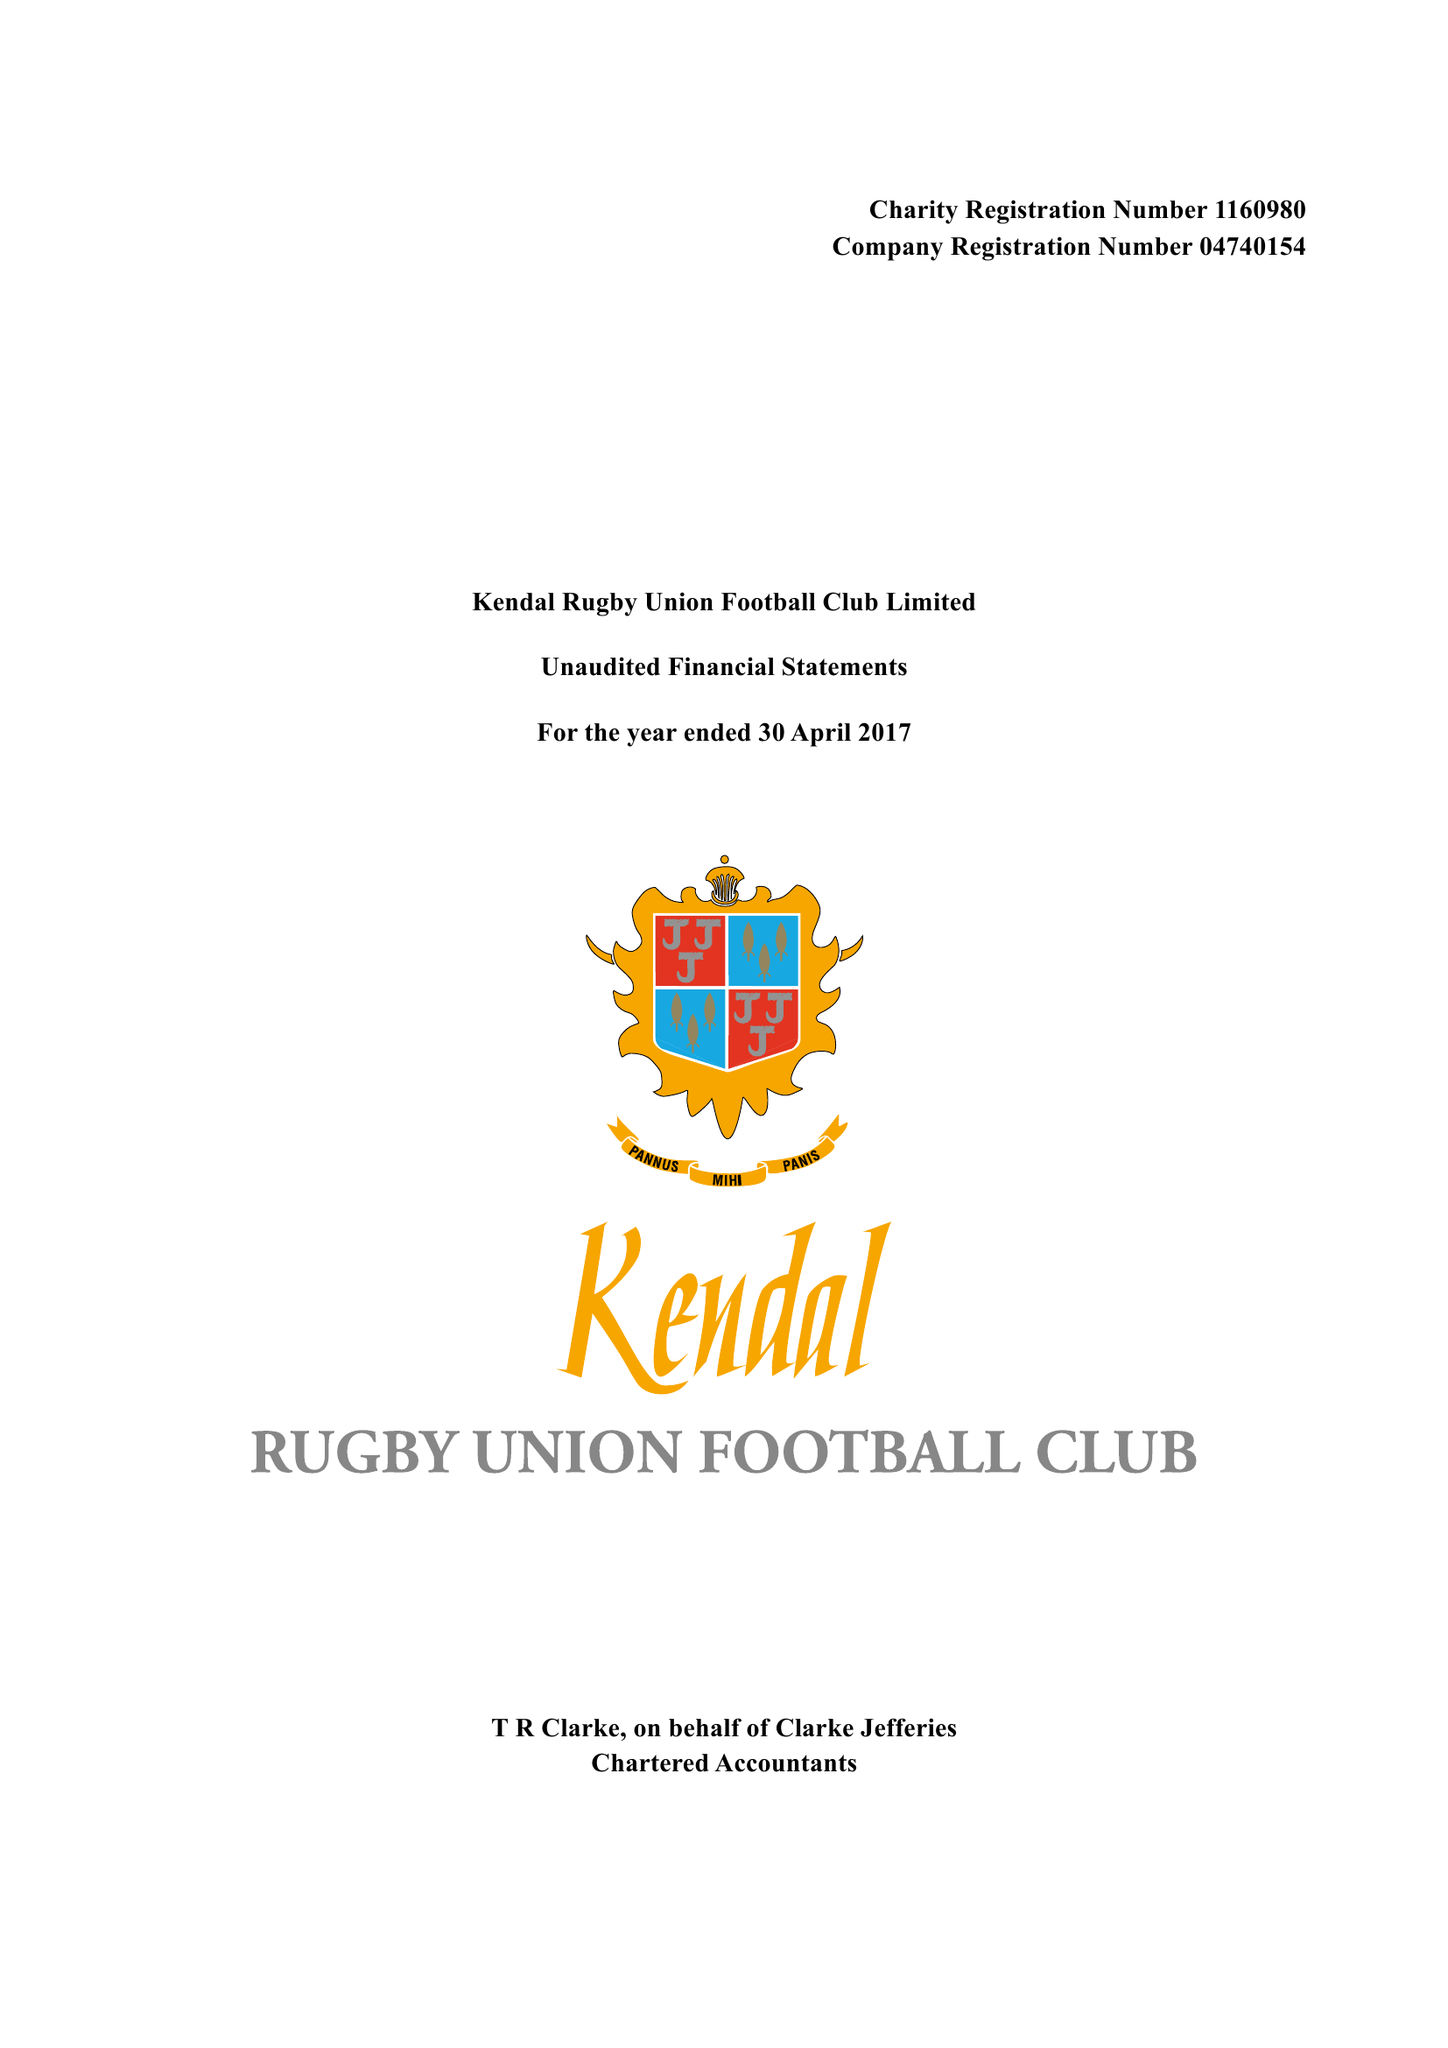What is the value for the report_date?
Answer the question using a single word or phrase. 2017-04-30 